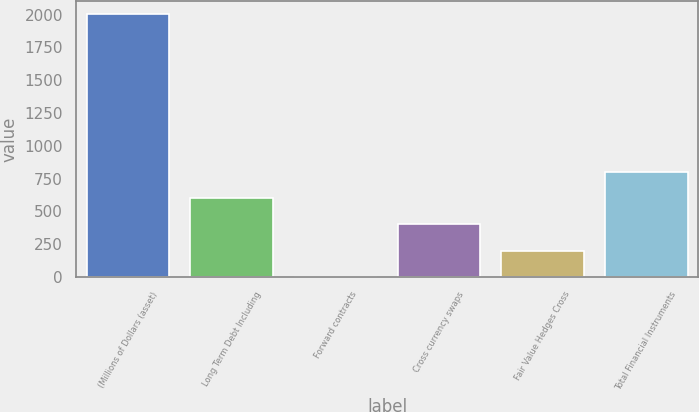Convert chart. <chart><loc_0><loc_0><loc_500><loc_500><bar_chart><fcel>(Millions of Dollars (asset)<fcel>Long Term Debt Including<fcel>Forward contracts<fcel>Cross currency swaps<fcel>Fair Value Hedges Cross<fcel>Total Financial Instruments<nl><fcel>2004<fcel>601.27<fcel>0.1<fcel>400.88<fcel>200.49<fcel>801.66<nl></chart> 